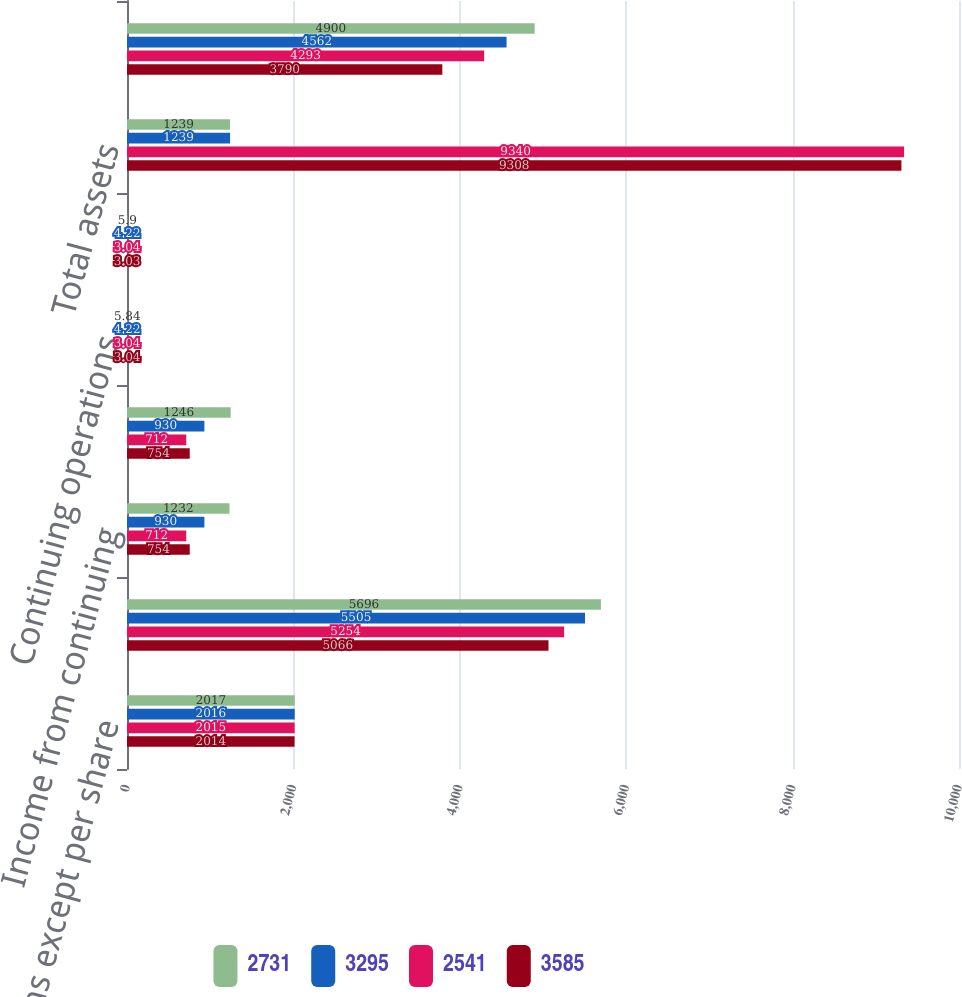Convert chart to OTSL. <chart><loc_0><loc_0><loc_500><loc_500><stacked_bar_chart><ecel><fcel>(In millions except per share<fcel>Total revenue<fcel>Income from continuing<fcel>Net income<fcel>Continuing operations<fcel>Total<fcel>Total assets<fcel>Long-term debt (including<nl><fcel>2731<fcel>2017<fcel>5696<fcel>1232<fcel>1246<fcel>5.84<fcel>5.9<fcel>1239<fcel>4900<nl><fcel>3295<fcel>2016<fcel>5505<fcel>930<fcel>930<fcel>4.22<fcel>4.22<fcel>1239<fcel>4562<nl><fcel>2541<fcel>2015<fcel>5254<fcel>712<fcel>712<fcel>3.04<fcel>3.04<fcel>9340<fcel>4293<nl><fcel>3585<fcel>2014<fcel>5066<fcel>754<fcel>754<fcel>3.04<fcel>3.03<fcel>9308<fcel>3790<nl></chart> 